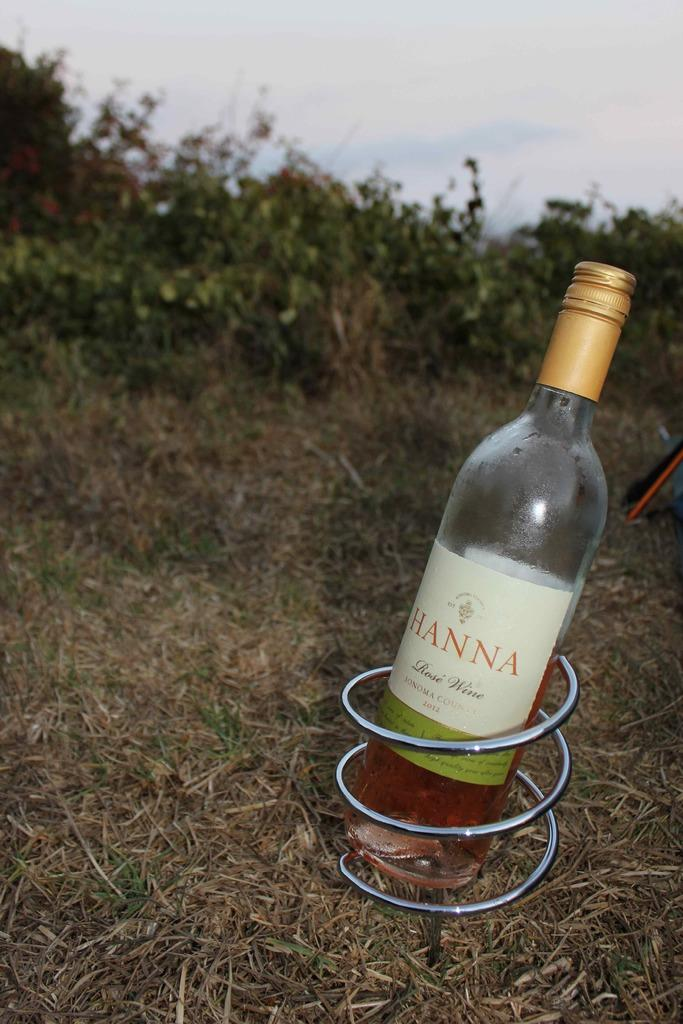<image>
Present a compact description of the photo's key features. Bottle of Hanna rose wine sonoma county on some grass 